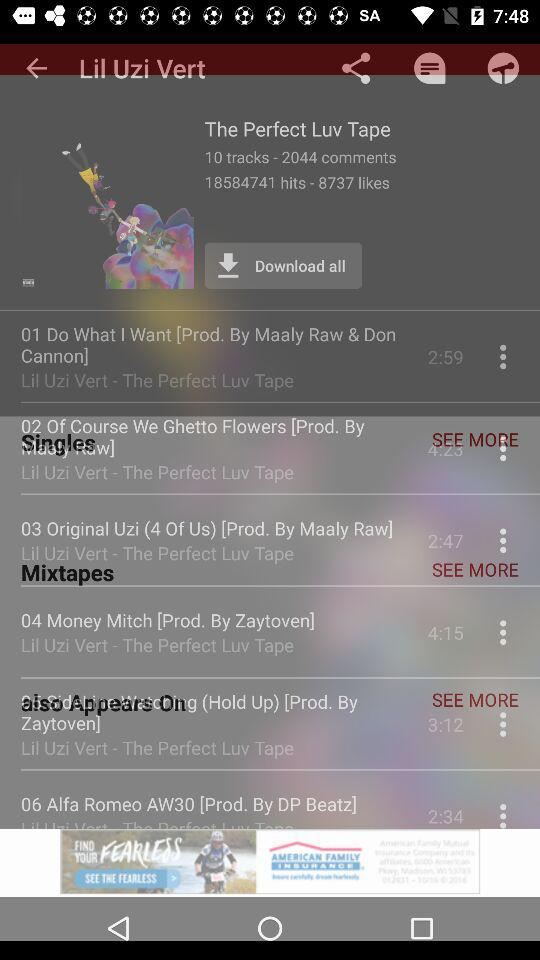What is the duration of "Do What I Want"? The duration is 2 minutes 59 seconds. 